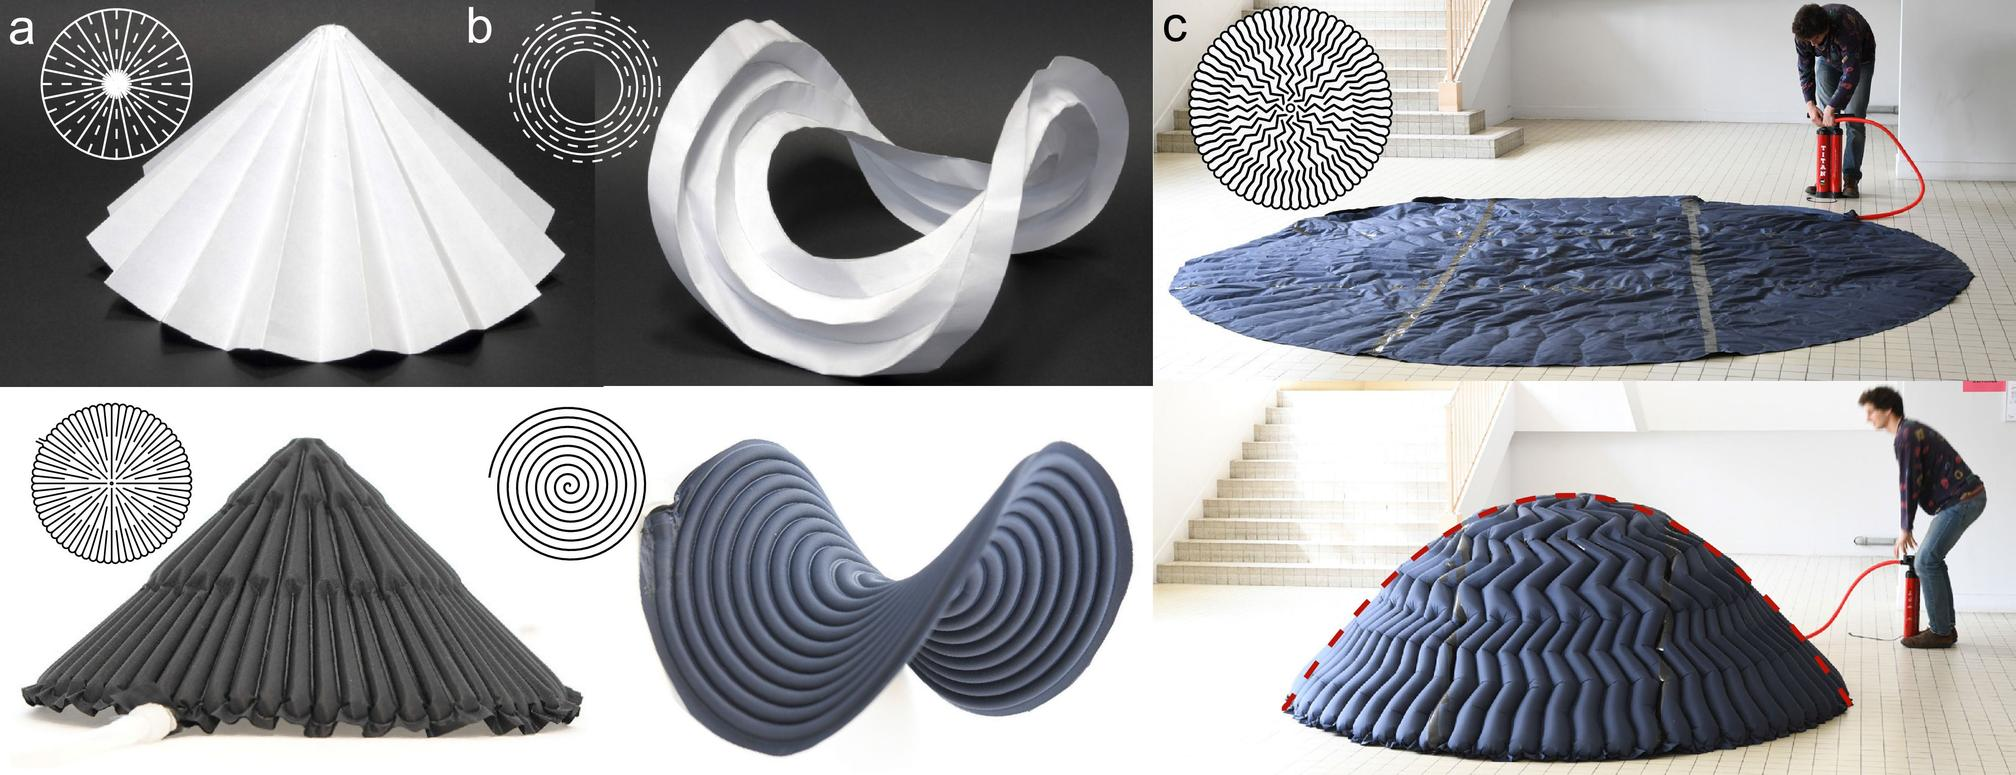Can you explain how the technique used in figure (a) can be applied in architectural design? The technique demonstrated in figure (a), known as origami folding, can be applied in architectural design to create innovative and efficient structures. Architects use these folding techniques to explore how flat materials can be converted into self-supporting forms that are both aesthetic and functional. Such designs can lead to the development of buildings that are not only visually captivating but also environmentally responsive and structurally sound. 